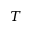Convert formula to latex. <formula><loc_0><loc_0><loc_500><loc_500>T</formula> 